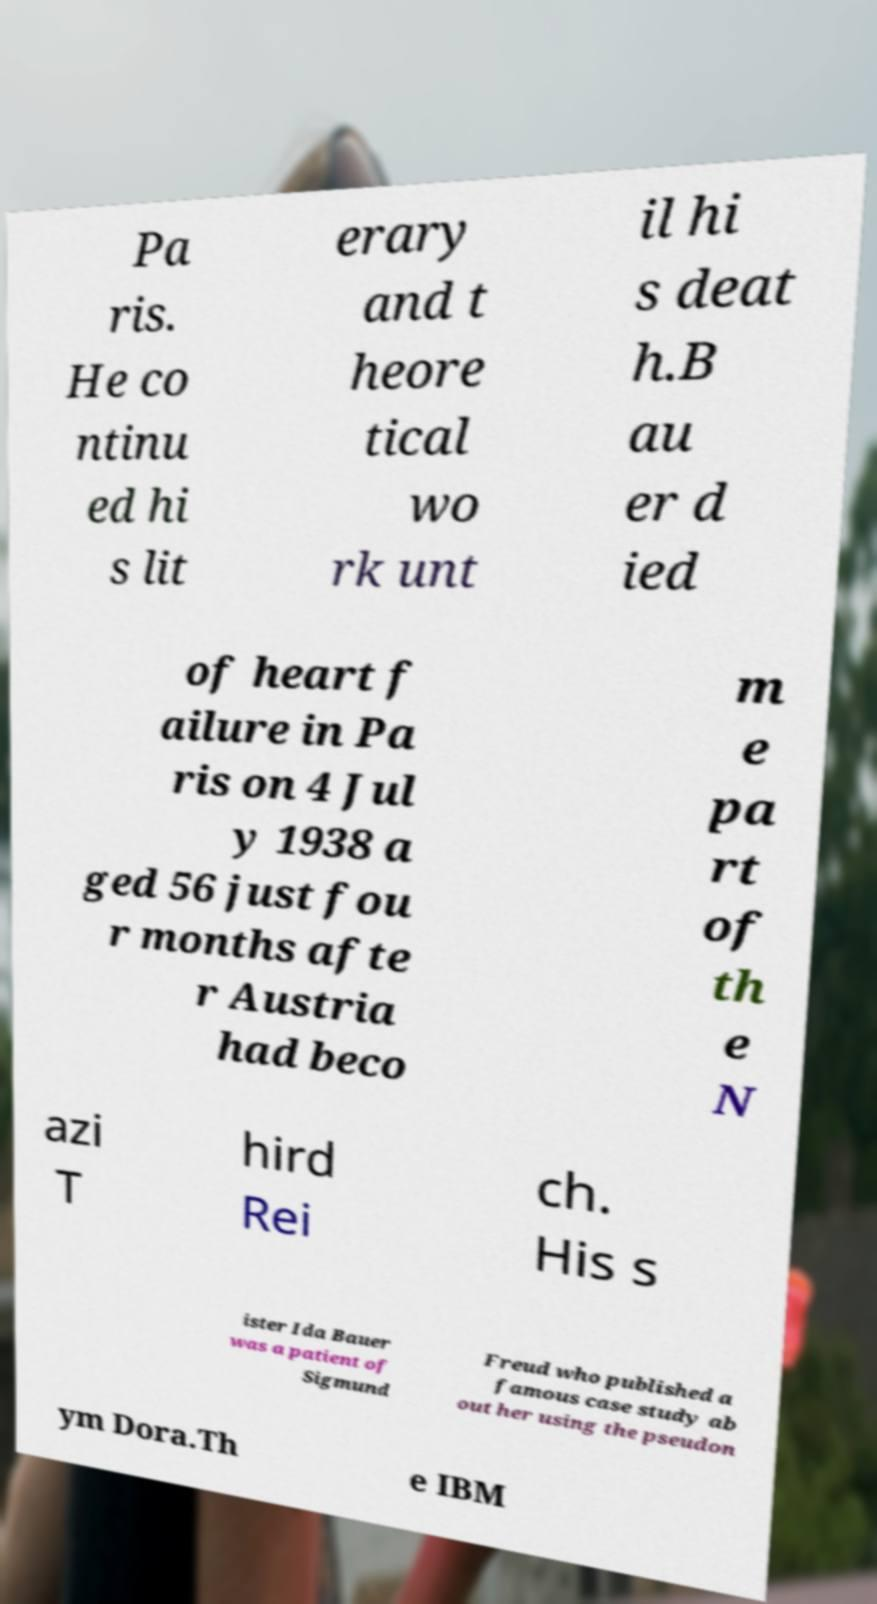Could you assist in decoding the text presented in this image and type it out clearly? Pa ris. He co ntinu ed hi s lit erary and t heore tical wo rk unt il hi s deat h.B au er d ied of heart f ailure in Pa ris on 4 Jul y 1938 a ged 56 just fou r months afte r Austria had beco m e pa rt of th e N azi T hird Rei ch. His s ister Ida Bauer was a patient of Sigmund Freud who published a famous case study ab out her using the pseudon ym Dora.Th e IBM 